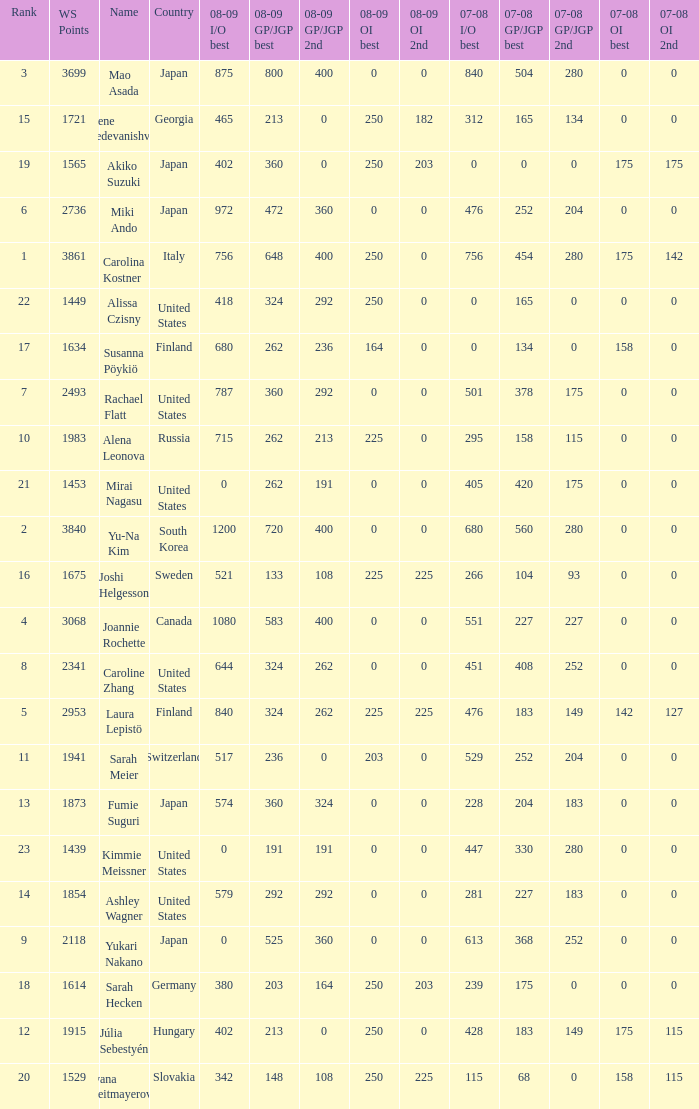08-09 gp/jgp 2nd is 213 and ws points will be what maximum 1983.0. 